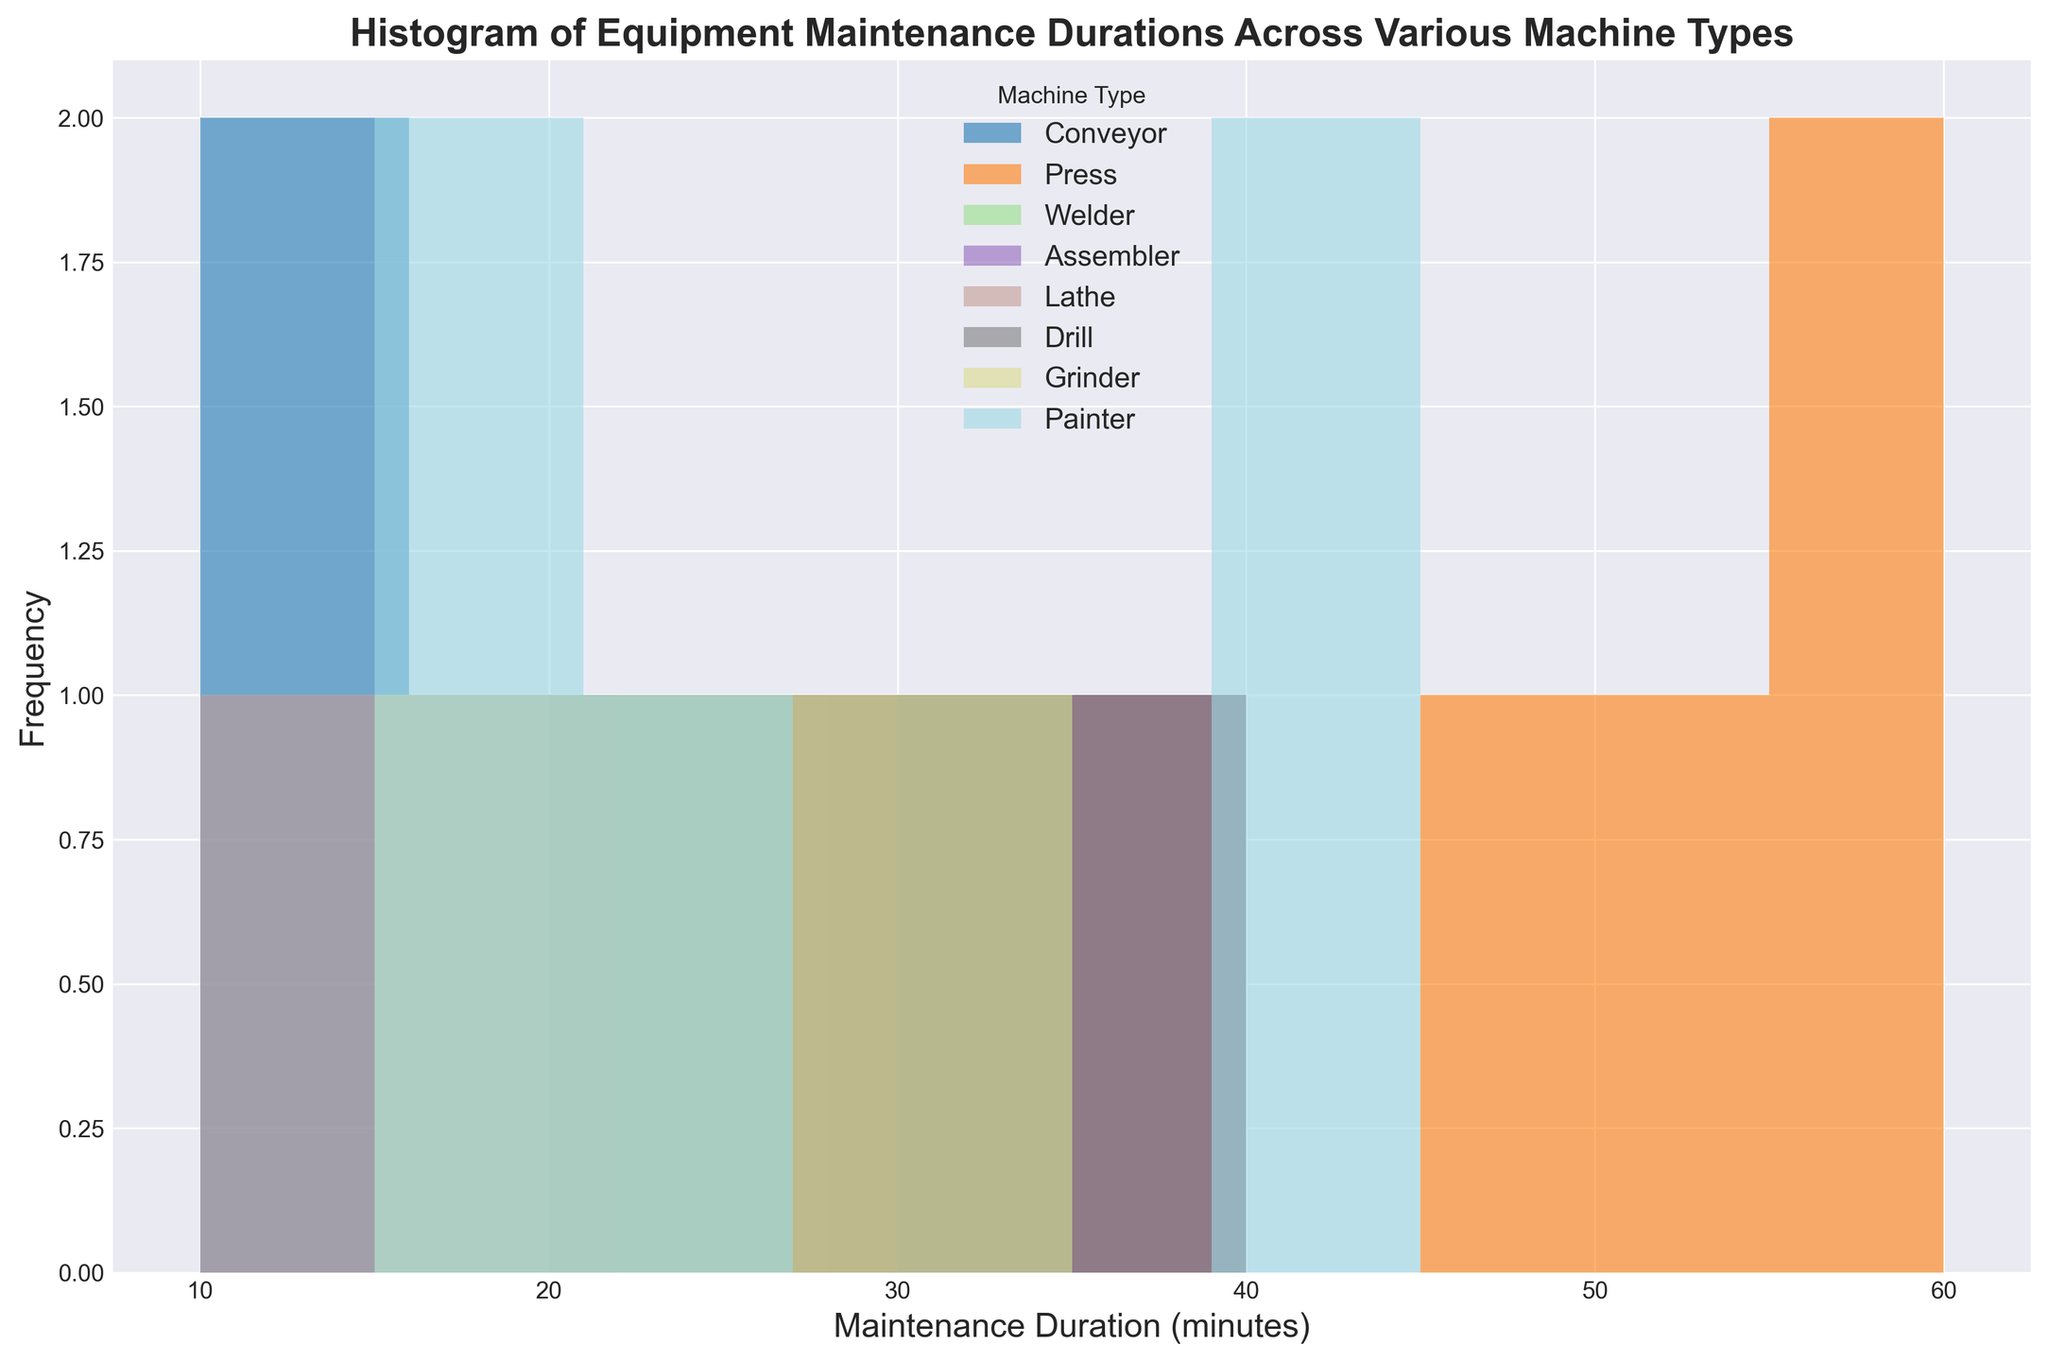What is the most common maintenance duration for Conveyor machines? To determine the most common maintenance duration, we look at the peak of the histogram for Conveyor machines. The mode is the duration with the highest frequency.
Answer: 20 minutes Which machine type has the longest maintenance durations on average? To find this, we observe the distribution of each machine type and note which has the higher maintenance durations. Press machines have durations clustered around higher values.
Answer: Press What is the range of maintenance durations for Drill machines? The range is calculated by subtracting the shortest duration from the longest. For Drill machines, the shortest duration is 20 minutes and the longest is 40 minutes. Thus, the range is 40 - 20 = 20 minutes.
Answer: 20 minutes Compare the frequency of maintenance durations around 30 minutes for Welder and Assembler machines. To answer this, observe the height of the bars around the 30-minute mark for each machine. Welder has one bar around 30 minutes while Assembler has multiple bars with a higher collective frequency around 30 minutes.
Answer: Assembler Which machine type shows the greatest variation in maintenance durations? Variation is indicated by the spread and number of distinct bars. The Press machine shows a wide spread from 35 to 60 minutes.
Answer: Press What is the total number of maintenance occurrences recorded for Grinder machines? Counting the number of occurrences recorded for Grinder machines in the histogram. Grinder has 5 occurrences at 15, 20, 25, 30, and 35 minutes.
Answer: 5 How many more maintenance tasks taking 45 minutes are there compared to those taking 40 minutes for Press machines? We look at the height of the bars for 45 and 40 minutes. There is 1 bar for 40 minutes and 1 bar for 45 minutes for Press machines, so the difference is 0.
Answer: 0 What is the average maintenance duration for Lathe machines? Adding up the durations for Lathe (10, 20, 30, 25, 15) totals 100 minutes. Dividing by the number of records (5) gives an average of 20 minutes.
Answer: 20 minutes Which machine type has the highest peak frequency in the 10-20 minutes duration range? Observing the height of the bars within 10-20 minutes for each machine type, Conveyor has the highest frequency bar at 10 and 15 minutes.
Answer: Conveyor 